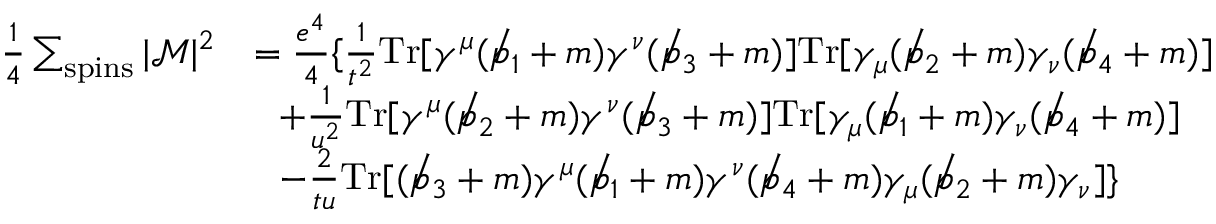Convert formula to latex. <formula><loc_0><loc_0><loc_500><loc_500>{ \begin{array} { r l } { { \frac { 1 } { 4 } } \sum _ { s p i n s } | { \mathcal { M } } | ^ { 2 } } & { = { \frac { e ^ { 4 } } { 4 } } \{ { \frac { 1 } { t ^ { 2 } } } T r [ \gamma ^ { \mu } ( \not p _ { 1 } + m ) \gamma ^ { \nu } ( \not p _ { 3 } + m ) ] T r [ \gamma _ { \mu } ( \not p _ { 2 } + m ) \gamma _ { \nu } ( \not p _ { 4 } + m ) ] } \\ & { + { \frac { 1 } { u ^ { 2 } } } T r [ \gamma ^ { \mu } ( \not p _ { 2 } + m ) \gamma ^ { \nu } ( \not p _ { 3 } + m ) ] T r [ \gamma _ { \mu } ( \not p _ { 1 } + m ) \gamma _ { \nu } ( \not p _ { 4 } + m ) ] } \\ & { - { \frac { 2 } { t u } } T r [ ( \not p _ { 3 } + m ) \gamma ^ { \mu } ( \not p _ { 1 } + m ) \gamma ^ { \nu } ( \not p _ { 4 } + m ) \gamma _ { \mu } ( \not p _ { 2 } + m ) \gamma _ { \nu } ] \} } \end{array} }</formula> 